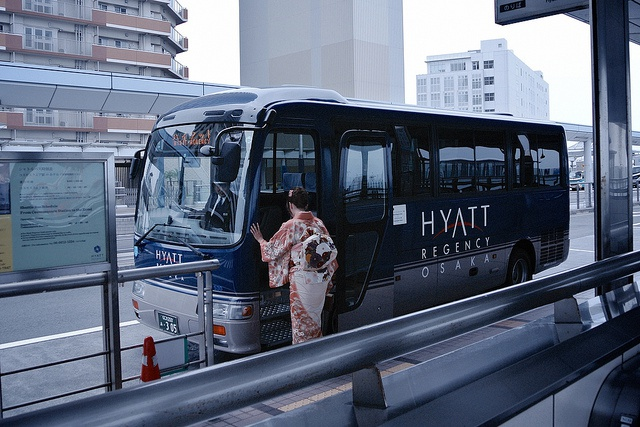Describe the objects in this image and their specific colors. I can see bus in gray, black, navy, and darkgray tones, people in gray, darkgray, and black tones, and people in gray, black, navy, and darkblue tones in this image. 